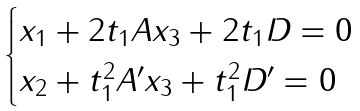<formula> <loc_0><loc_0><loc_500><loc_500>\begin{cases} x _ { 1 } + 2 t _ { 1 } A x _ { 3 } + 2 t _ { 1 } D = 0 \\ x _ { 2 } + t _ { 1 } ^ { 2 } A ^ { \prime } x _ { 3 } + t _ { 1 } ^ { 2 } D ^ { \prime } = 0 \end{cases}</formula> 